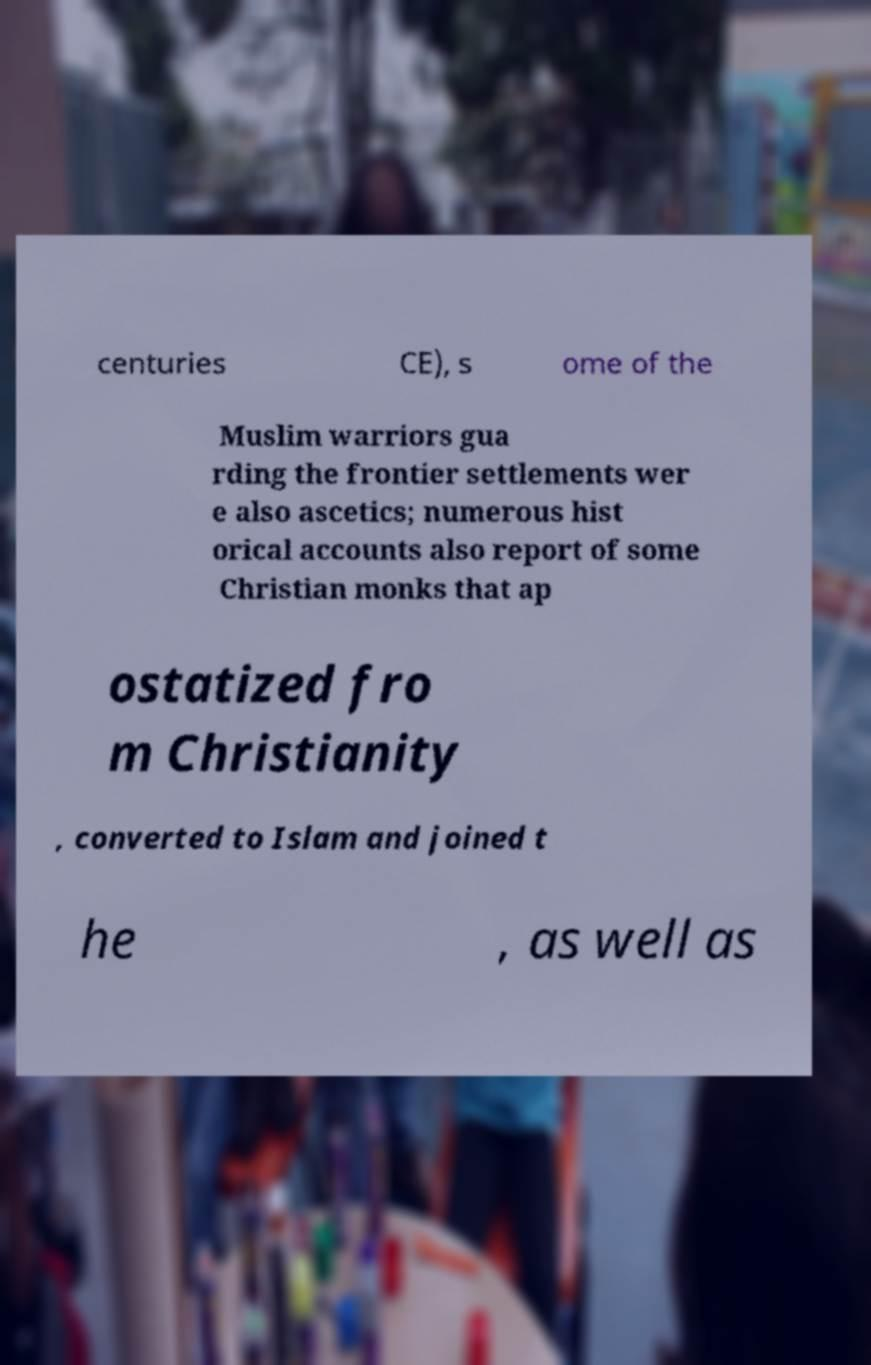Please identify and transcribe the text found in this image. centuries CE), s ome of the Muslim warriors gua rding the frontier settlements wer e also ascetics; numerous hist orical accounts also report of some Christian monks that ap ostatized fro m Christianity , converted to Islam and joined t he , as well as 